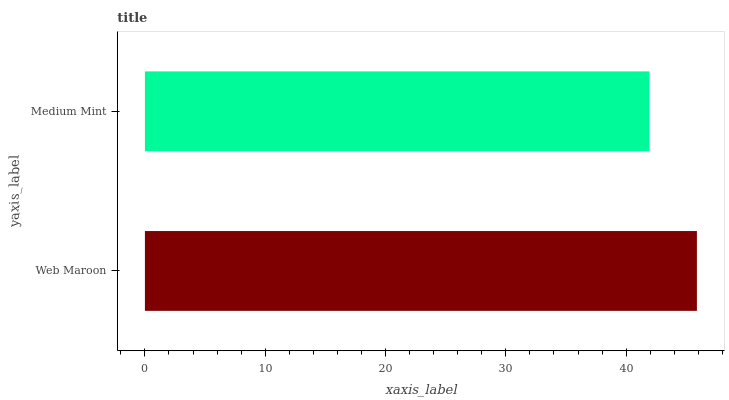Is Medium Mint the minimum?
Answer yes or no. Yes. Is Web Maroon the maximum?
Answer yes or no. Yes. Is Medium Mint the maximum?
Answer yes or no. No. Is Web Maroon greater than Medium Mint?
Answer yes or no. Yes. Is Medium Mint less than Web Maroon?
Answer yes or no. Yes. Is Medium Mint greater than Web Maroon?
Answer yes or no. No. Is Web Maroon less than Medium Mint?
Answer yes or no. No. Is Web Maroon the high median?
Answer yes or no. Yes. Is Medium Mint the low median?
Answer yes or no. Yes. Is Medium Mint the high median?
Answer yes or no. No. Is Web Maroon the low median?
Answer yes or no. No. 